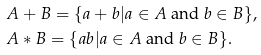Convert formula to latex. <formula><loc_0><loc_0><loc_500><loc_500>& A + B = \{ a + b | a \in A \text { and } b \in B \} , \\ & A * B = \{ a b | a \in A \text { and } b \in B \} .</formula> 